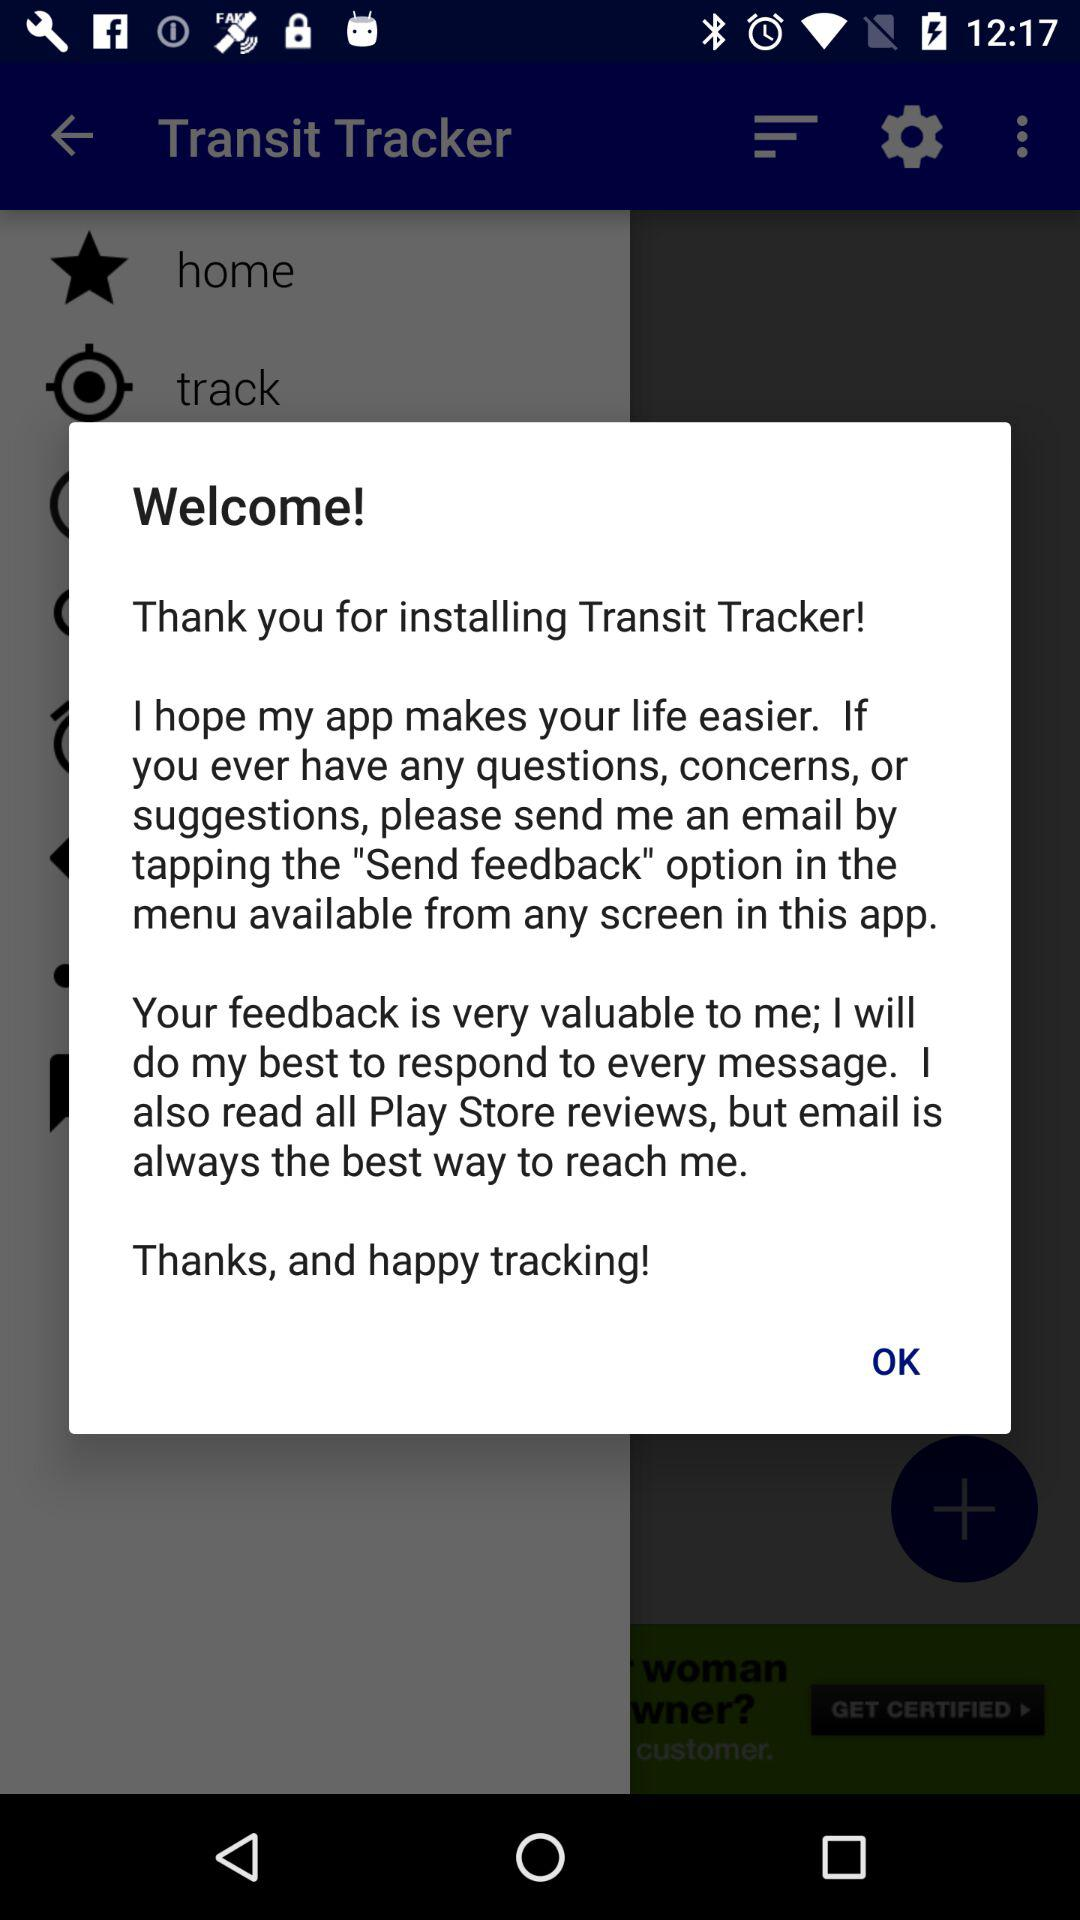What is the name of the application? The name of the application is "Transit Tracker". 